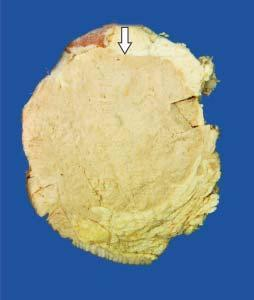what is somewhat delineated from the adjacent breast parenchyma as compared to irregular margin of idc?
Answer the question using a single word or phrase. Tumour 